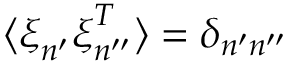<formula> <loc_0><loc_0><loc_500><loc_500>\langle \xi _ { n ^ { \prime } } \xi _ { n ^ { \prime \prime } } ^ { T } \rangle = \delta _ { n ^ { \prime } n ^ { \prime \prime } }</formula> 